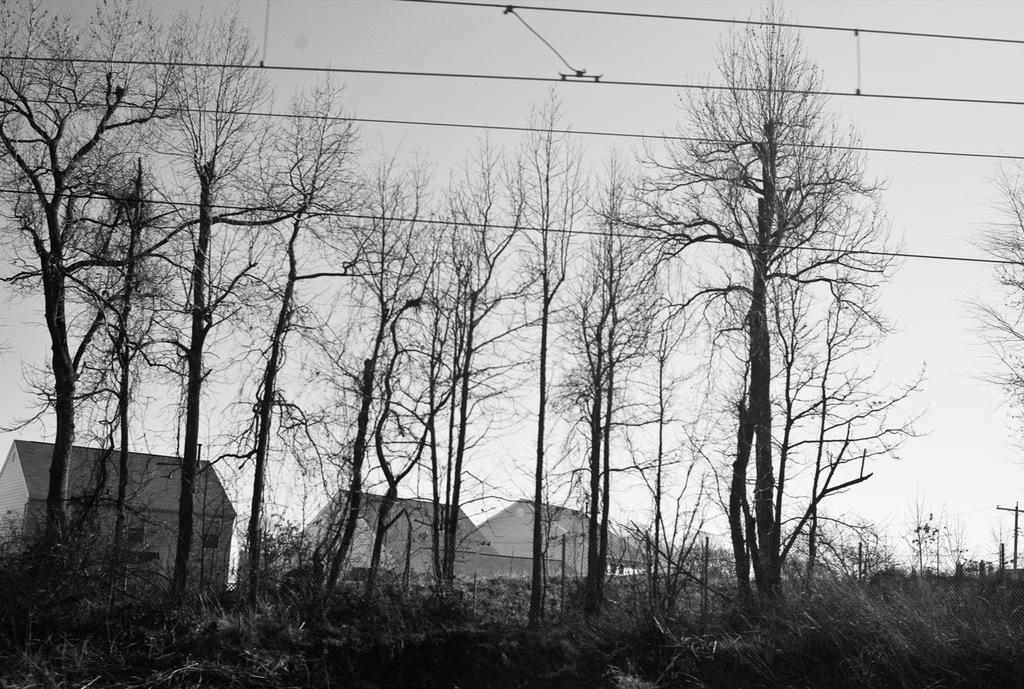Describe this image in one or two sentences. This is a black and white image. In this image we can see a group of trees, plants, some houses with roof, some poles, wires and the sky which looks cloudy. 